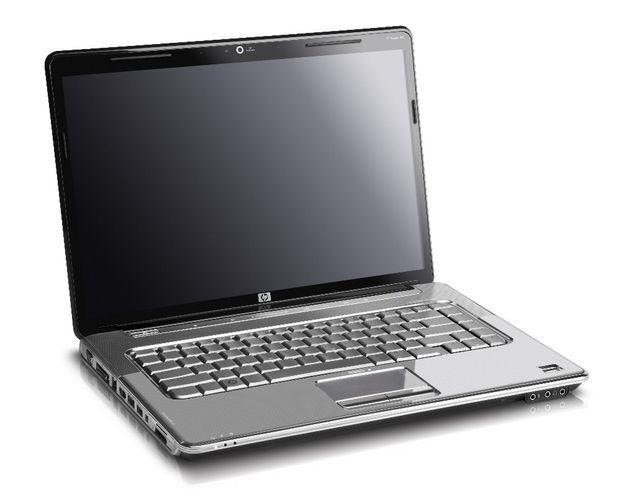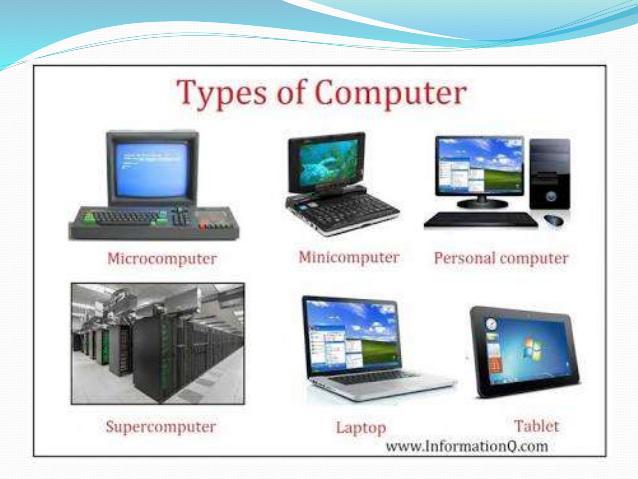The first image is the image on the left, the second image is the image on the right. For the images shown, is this caption "The laptop in the image on the left is facing right." true? Answer yes or no. Yes. 